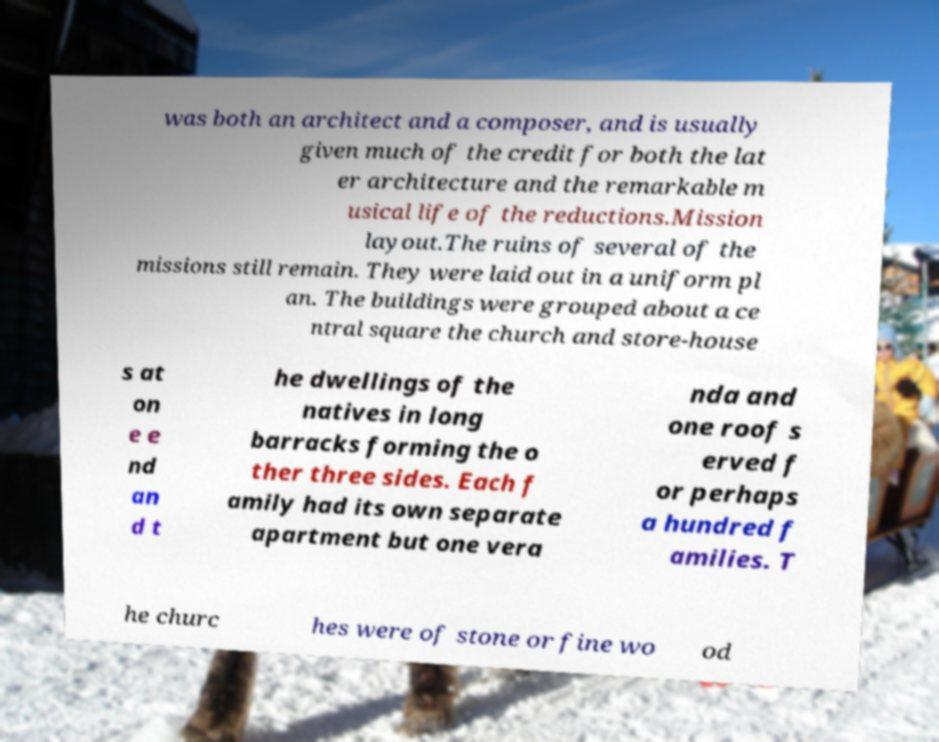What messages or text are displayed in this image? I need them in a readable, typed format. was both an architect and a composer, and is usually given much of the credit for both the lat er architecture and the remarkable m usical life of the reductions.Mission layout.The ruins of several of the missions still remain. They were laid out in a uniform pl an. The buildings were grouped about a ce ntral square the church and store-house s at on e e nd an d t he dwellings of the natives in long barracks forming the o ther three sides. Each f amily had its own separate apartment but one vera nda and one roof s erved f or perhaps a hundred f amilies. T he churc hes were of stone or fine wo od 